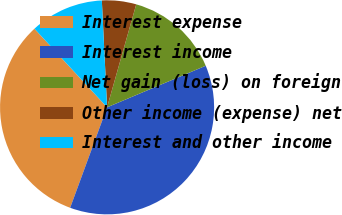Convert chart to OTSL. <chart><loc_0><loc_0><loc_500><loc_500><pie_chart><fcel>Interest expense<fcel>Interest income<fcel>Net gain (loss) on foreign<fcel>Other income (expense) net<fcel>Interest and other income<nl><fcel>32.52%<fcel>36.95%<fcel>14.26%<fcel>5.17%<fcel>11.09%<nl></chart> 